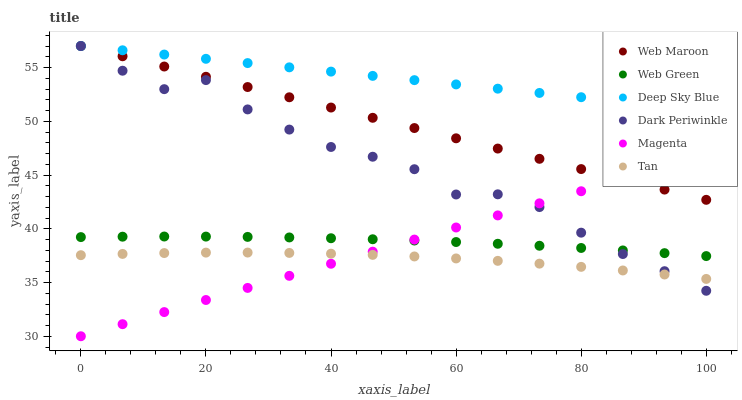Does Tan have the minimum area under the curve?
Answer yes or no. Yes. Does Deep Sky Blue have the maximum area under the curve?
Answer yes or no. Yes. Does Web Green have the minimum area under the curve?
Answer yes or no. No. Does Web Green have the maximum area under the curve?
Answer yes or no. No. Is Deep Sky Blue the smoothest?
Answer yes or no. Yes. Is Dark Periwinkle the roughest?
Answer yes or no. Yes. Is Web Green the smoothest?
Answer yes or no. No. Is Web Green the roughest?
Answer yes or no. No. Does Magenta have the lowest value?
Answer yes or no. Yes. Does Web Green have the lowest value?
Answer yes or no. No. Does Deep Sky Blue have the highest value?
Answer yes or no. Yes. Does Web Green have the highest value?
Answer yes or no. No. Is Tan less than Deep Sky Blue?
Answer yes or no. Yes. Is Web Maroon greater than Web Green?
Answer yes or no. Yes. Does Dark Periwinkle intersect Web Green?
Answer yes or no. Yes. Is Dark Periwinkle less than Web Green?
Answer yes or no. No. Is Dark Periwinkle greater than Web Green?
Answer yes or no. No. Does Tan intersect Deep Sky Blue?
Answer yes or no. No. 